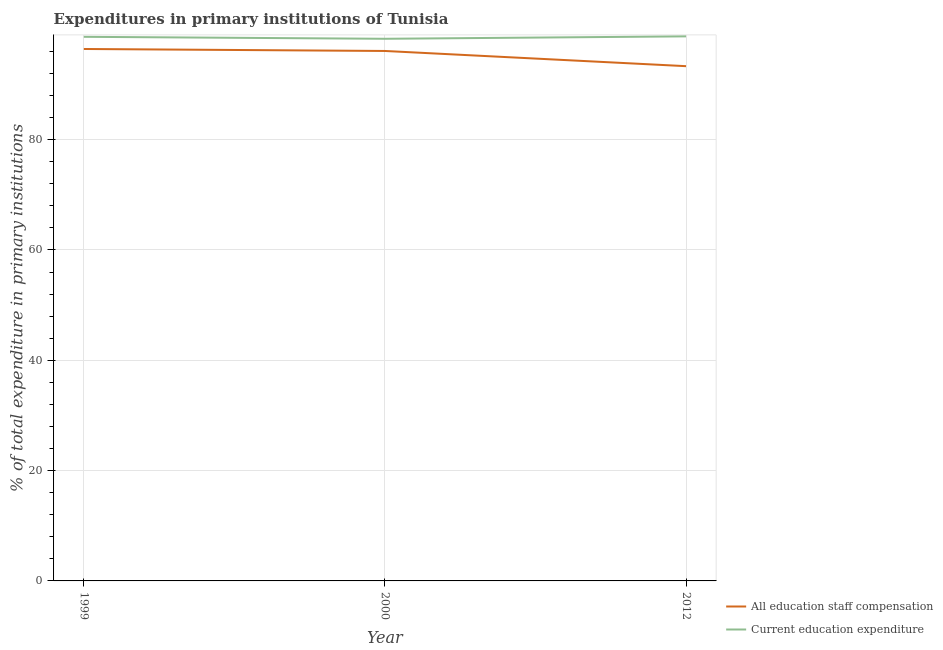How many different coloured lines are there?
Your response must be concise. 2. Is the number of lines equal to the number of legend labels?
Provide a succinct answer. Yes. What is the expenditure in education in 1999?
Give a very brief answer. 98.64. Across all years, what is the maximum expenditure in education?
Your answer should be very brief. 98.72. Across all years, what is the minimum expenditure in education?
Your answer should be compact. 98.28. In which year was the expenditure in education maximum?
Offer a very short reply. 2012. What is the total expenditure in staff compensation in the graph?
Ensure brevity in your answer.  285.83. What is the difference between the expenditure in education in 1999 and that in 2000?
Ensure brevity in your answer.  0.36. What is the difference between the expenditure in education in 2012 and the expenditure in staff compensation in 2000?
Offer a very short reply. 2.65. What is the average expenditure in education per year?
Ensure brevity in your answer.  98.55. In the year 2000, what is the difference between the expenditure in staff compensation and expenditure in education?
Ensure brevity in your answer.  -2.21. In how many years, is the expenditure in education greater than 48 %?
Give a very brief answer. 3. What is the ratio of the expenditure in staff compensation in 1999 to that in 2000?
Your answer should be compact. 1. Is the difference between the expenditure in staff compensation in 1999 and 2012 greater than the difference between the expenditure in education in 1999 and 2012?
Your answer should be very brief. Yes. What is the difference between the highest and the second highest expenditure in education?
Offer a very short reply. 0.08. What is the difference between the highest and the lowest expenditure in staff compensation?
Provide a succinct answer. 3.12. Does the expenditure in staff compensation monotonically increase over the years?
Offer a terse response. No. How many lines are there?
Provide a succinct answer. 2. How many years are there in the graph?
Offer a terse response. 3. Does the graph contain any zero values?
Your response must be concise. No. Where does the legend appear in the graph?
Provide a succinct answer. Bottom right. How many legend labels are there?
Your answer should be very brief. 2. How are the legend labels stacked?
Provide a short and direct response. Vertical. What is the title of the graph?
Offer a terse response. Expenditures in primary institutions of Tunisia. Does "Under-5(female)" appear as one of the legend labels in the graph?
Ensure brevity in your answer.  No. What is the label or title of the X-axis?
Offer a very short reply. Year. What is the label or title of the Y-axis?
Offer a very short reply. % of total expenditure in primary institutions. What is the % of total expenditure in primary institutions of All education staff compensation in 1999?
Make the answer very short. 96.43. What is the % of total expenditure in primary institutions of Current education expenditure in 1999?
Provide a short and direct response. 98.64. What is the % of total expenditure in primary institutions in All education staff compensation in 2000?
Give a very brief answer. 96.07. What is the % of total expenditure in primary institutions in Current education expenditure in 2000?
Ensure brevity in your answer.  98.28. What is the % of total expenditure in primary institutions of All education staff compensation in 2012?
Your answer should be compact. 93.32. What is the % of total expenditure in primary institutions of Current education expenditure in 2012?
Your response must be concise. 98.72. Across all years, what is the maximum % of total expenditure in primary institutions of All education staff compensation?
Ensure brevity in your answer.  96.43. Across all years, what is the maximum % of total expenditure in primary institutions of Current education expenditure?
Give a very brief answer. 98.72. Across all years, what is the minimum % of total expenditure in primary institutions of All education staff compensation?
Offer a terse response. 93.32. Across all years, what is the minimum % of total expenditure in primary institutions in Current education expenditure?
Keep it short and to the point. 98.28. What is the total % of total expenditure in primary institutions in All education staff compensation in the graph?
Offer a terse response. 285.83. What is the total % of total expenditure in primary institutions of Current education expenditure in the graph?
Provide a succinct answer. 295.65. What is the difference between the % of total expenditure in primary institutions of All education staff compensation in 1999 and that in 2000?
Give a very brief answer. 0.36. What is the difference between the % of total expenditure in primary institutions of Current education expenditure in 1999 and that in 2000?
Give a very brief answer. 0.36. What is the difference between the % of total expenditure in primary institutions in All education staff compensation in 1999 and that in 2012?
Make the answer very short. 3.12. What is the difference between the % of total expenditure in primary institutions of Current education expenditure in 1999 and that in 2012?
Your answer should be compact. -0.08. What is the difference between the % of total expenditure in primary institutions in All education staff compensation in 2000 and that in 2012?
Your response must be concise. 2.76. What is the difference between the % of total expenditure in primary institutions in Current education expenditure in 2000 and that in 2012?
Offer a very short reply. -0.44. What is the difference between the % of total expenditure in primary institutions in All education staff compensation in 1999 and the % of total expenditure in primary institutions in Current education expenditure in 2000?
Offer a terse response. -1.85. What is the difference between the % of total expenditure in primary institutions in All education staff compensation in 1999 and the % of total expenditure in primary institutions in Current education expenditure in 2012?
Ensure brevity in your answer.  -2.29. What is the difference between the % of total expenditure in primary institutions in All education staff compensation in 2000 and the % of total expenditure in primary institutions in Current education expenditure in 2012?
Keep it short and to the point. -2.65. What is the average % of total expenditure in primary institutions in All education staff compensation per year?
Provide a succinct answer. 95.28. What is the average % of total expenditure in primary institutions of Current education expenditure per year?
Give a very brief answer. 98.55. In the year 1999, what is the difference between the % of total expenditure in primary institutions in All education staff compensation and % of total expenditure in primary institutions in Current education expenditure?
Offer a very short reply. -2.21. In the year 2000, what is the difference between the % of total expenditure in primary institutions in All education staff compensation and % of total expenditure in primary institutions in Current education expenditure?
Keep it short and to the point. -2.21. In the year 2012, what is the difference between the % of total expenditure in primary institutions in All education staff compensation and % of total expenditure in primary institutions in Current education expenditure?
Offer a very short reply. -5.4. What is the ratio of the % of total expenditure in primary institutions of All education staff compensation in 1999 to that in 2000?
Your response must be concise. 1. What is the ratio of the % of total expenditure in primary institutions in Current education expenditure in 1999 to that in 2000?
Your answer should be very brief. 1. What is the ratio of the % of total expenditure in primary institutions in All education staff compensation in 1999 to that in 2012?
Keep it short and to the point. 1.03. What is the ratio of the % of total expenditure in primary institutions of Current education expenditure in 1999 to that in 2012?
Keep it short and to the point. 1. What is the ratio of the % of total expenditure in primary institutions in All education staff compensation in 2000 to that in 2012?
Your answer should be compact. 1.03. What is the ratio of the % of total expenditure in primary institutions of Current education expenditure in 2000 to that in 2012?
Keep it short and to the point. 1. What is the difference between the highest and the second highest % of total expenditure in primary institutions in All education staff compensation?
Ensure brevity in your answer.  0.36. What is the difference between the highest and the second highest % of total expenditure in primary institutions of Current education expenditure?
Ensure brevity in your answer.  0.08. What is the difference between the highest and the lowest % of total expenditure in primary institutions of All education staff compensation?
Your answer should be very brief. 3.12. What is the difference between the highest and the lowest % of total expenditure in primary institutions in Current education expenditure?
Provide a succinct answer. 0.44. 